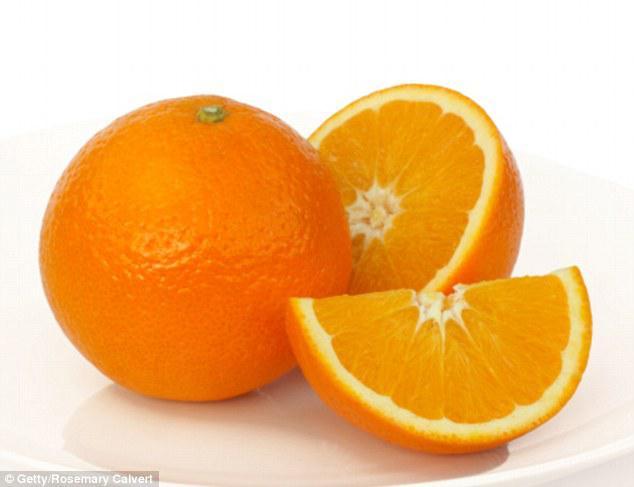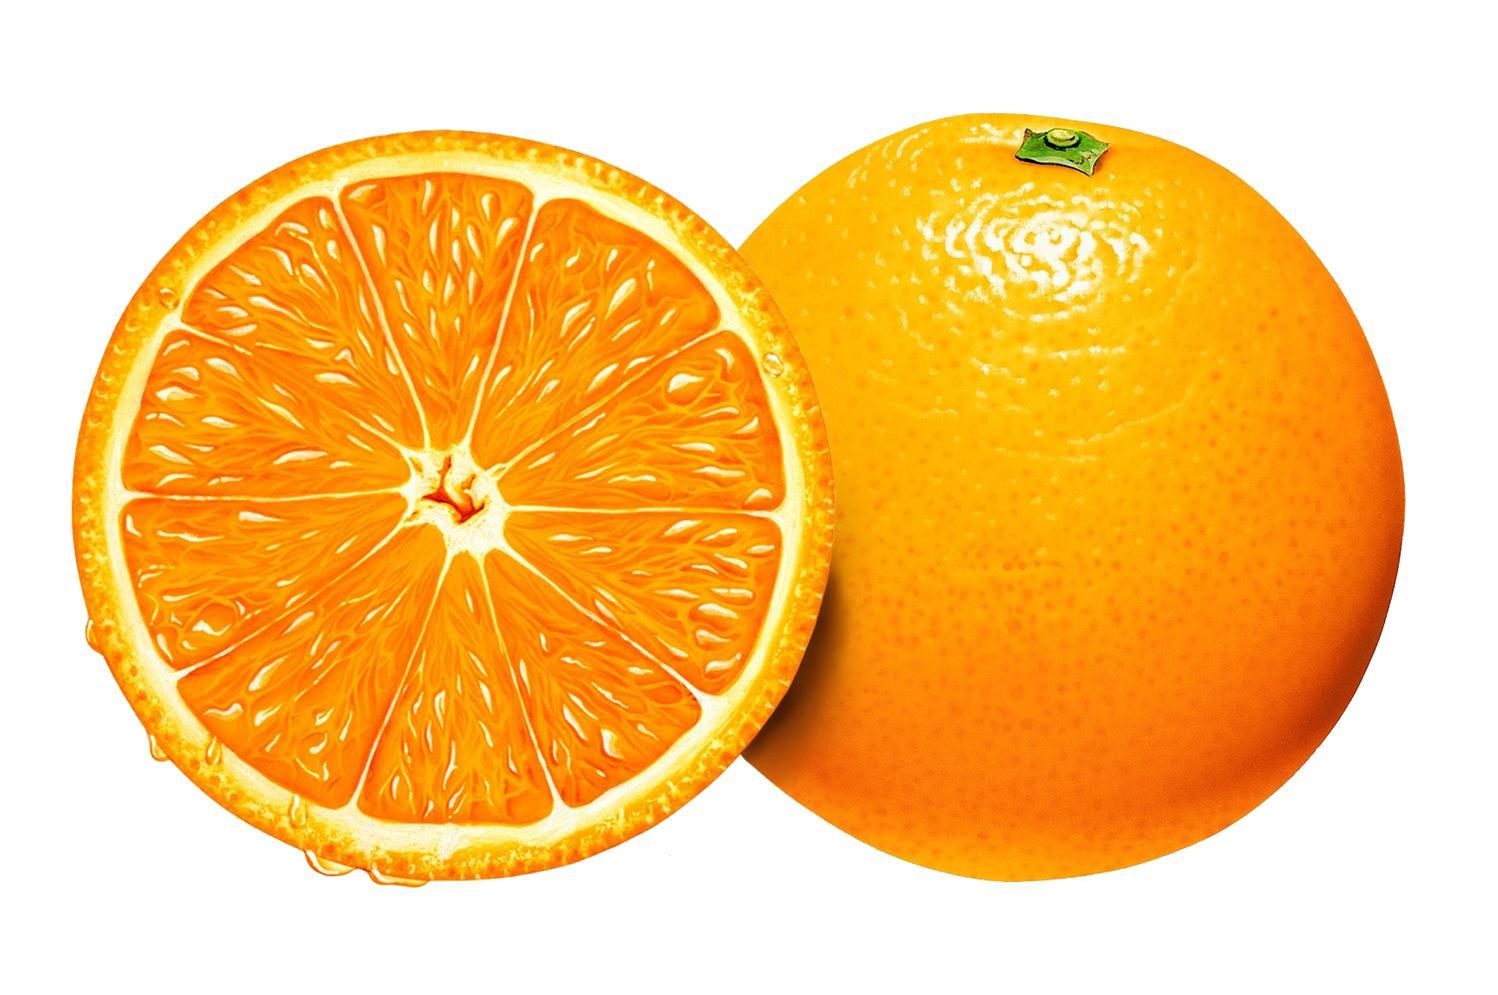The first image is the image on the left, the second image is the image on the right. For the images displayed, is the sentence "In one image, a woman is holding one or more slices of orange to her face, while a child in a second image is holding up an orange or part of one in each hand." factually correct? Answer yes or no. No. The first image is the image on the left, the second image is the image on the right. Assess this claim about the two images: "One person is holding an orange slice over at least one of their eyes.". Correct or not? Answer yes or no. No. 